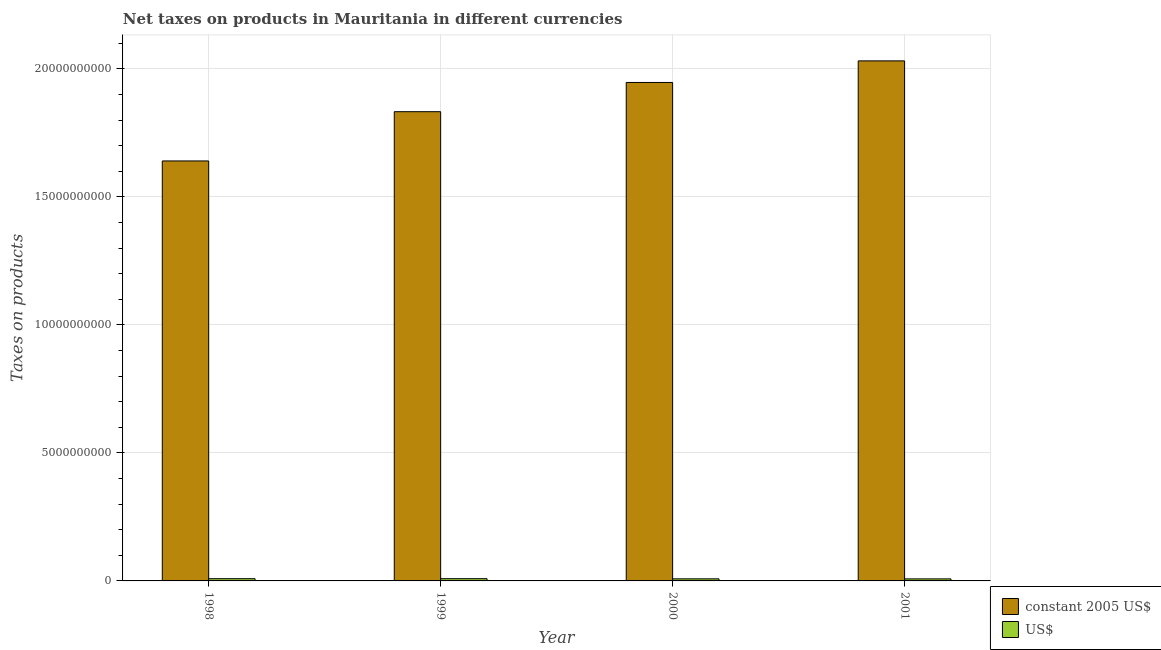Are the number of bars on each tick of the X-axis equal?
Your response must be concise. Yes. How many bars are there on the 3rd tick from the right?
Provide a succinct answer. 2. What is the label of the 4th group of bars from the left?
Give a very brief answer. 2001. What is the net taxes in us$ in 2000?
Give a very brief answer. 8.15e+07. Across all years, what is the maximum net taxes in constant 2005 us$?
Your answer should be very brief. 2.03e+1. Across all years, what is the minimum net taxes in us$?
Make the answer very short. 7.95e+07. In which year was the net taxes in us$ minimum?
Ensure brevity in your answer.  2001. What is the total net taxes in constant 2005 us$ in the graph?
Your response must be concise. 7.45e+1. What is the difference between the net taxes in us$ in 1998 and that in 2000?
Give a very brief answer. 5.55e+06. What is the difference between the net taxes in constant 2005 us$ in 2001 and the net taxes in us$ in 2000?
Your answer should be very brief. 8.43e+08. What is the average net taxes in us$ per year?
Ensure brevity in your answer.  8.39e+07. In the year 2000, what is the difference between the net taxes in constant 2005 us$ and net taxes in us$?
Offer a terse response. 0. In how many years, is the net taxes in constant 2005 us$ greater than 3000000000 units?
Offer a very short reply. 4. What is the ratio of the net taxes in constant 2005 us$ in 2000 to that in 2001?
Your answer should be compact. 0.96. Is the net taxes in us$ in 1999 less than that in 2000?
Provide a short and direct response. No. What is the difference between the highest and the second highest net taxes in constant 2005 us$?
Your answer should be compact. 8.43e+08. What is the difference between the highest and the lowest net taxes in constant 2005 us$?
Ensure brevity in your answer.  3.91e+09. What does the 1st bar from the left in 1999 represents?
Make the answer very short. Constant 2005 us$. What does the 1st bar from the right in 1999 represents?
Your answer should be very brief. US$. How many bars are there?
Offer a terse response. 8. Are all the bars in the graph horizontal?
Offer a terse response. No. What is the difference between two consecutive major ticks on the Y-axis?
Offer a very short reply. 5.00e+09. Does the graph contain any zero values?
Provide a succinct answer. No. Where does the legend appear in the graph?
Ensure brevity in your answer.  Bottom right. What is the title of the graph?
Provide a succinct answer. Net taxes on products in Mauritania in different currencies. What is the label or title of the X-axis?
Offer a very short reply. Year. What is the label or title of the Y-axis?
Your response must be concise. Taxes on products. What is the Taxes on products of constant 2005 US$ in 1998?
Your answer should be compact. 1.64e+1. What is the Taxes on products of US$ in 1998?
Ensure brevity in your answer.  8.70e+07. What is the Taxes on products in constant 2005 US$ in 1999?
Make the answer very short. 1.83e+1. What is the Taxes on products in US$ in 1999?
Keep it short and to the point. 8.75e+07. What is the Taxes on products of constant 2005 US$ in 2000?
Make the answer very short. 1.95e+1. What is the Taxes on products of US$ in 2000?
Your answer should be very brief. 8.15e+07. What is the Taxes on products in constant 2005 US$ in 2001?
Your answer should be very brief. 2.03e+1. What is the Taxes on products in US$ in 2001?
Make the answer very short. 7.95e+07. Across all years, what is the maximum Taxes on products of constant 2005 US$?
Provide a short and direct response. 2.03e+1. Across all years, what is the maximum Taxes on products in US$?
Ensure brevity in your answer.  8.75e+07. Across all years, what is the minimum Taxes on products in constant 2005 US$?
Offer a terse response. 1.64e+1. Across all years, what is the minimum Taxes on products in US$?
Give a very brief answer. 7.95e+07. What is the total Taxes on products in constant 2005 US$ in the graph?
Give a very brief answer. 7.45e+1. What is the total Taxes on products of US$ in the graph?
Your answer should be very brief. 3.35e+08. What is the difference between the Taxes on products in constant 2005 US$ in 1998 and that in 1999?
Give a very brief answer. -1.92e+09. What is the difference between the Taxes on products in US$ in 1998 and that in 1999?
Make the answer very short. -4.43e+05. What is the difference between the Taxes on products of constant 2005 US$ in 1998 and that in 2000?
Make the answer very short. -3.07e+09. What is the difference between the Taxes on products of US$ in 1998 and that in 2000?
Make the answer very short. 5.55e+06. What is the difference between the Taxes on products of constant 2005 US$ in 1998 and that in 2001?
Give a very brief answer. -3.91e+09. What is the difference between the Taxes on products in US$ in 1998 and that in 2001?
Keep it short and to the point. 7.57e+06. What is the difference between the Taxes on products in constant 2005 US$ in 1999 and that in 2000?
Give a very brief answer. -1.14e+09. What is the difference between the Taxes on products of US$ in 1999 and that in 2000?
Provide a succinct answer. 5.99e+06. What is the difference between the Taxes on products of constant 2005 US$ in 1999 and that in 2001?
Your answer should be very brief. -1.98e+09. What is the difference between the Taxes on products of US$ in 1999 and that in 2001?
Ensure brevity in your answer.  8.02e+06. What is the difference between the Taxes on products in constant 2005 US$ in 2000 and that in 2001?
Ensure brevity in your answer.  -8.43e+08. What is the difference between the Taxes on products of US$ in 2000 and that in 2001?
Offer a terse response. 2.03e+06. What is the difference between the Taxes on products in constant 2005 US$ in 1998 and the Taxes on products in US$ in 1999?
Offer a terse response. 1.63e+1. What is the difference between the Taxes on products in constant 2005 US$ in 1998 and the Taxes on products in US$ in 2000?
Provide a succinct answer. 1.63e+1. What is the difference between the Taxes on products of constant 2005 US$ in 1998 and the Taxes on products of US$ in 2001?
Provide a succinct answer. 1.63e+1. What is the difference between the Taxes on products in constant 2005 US$ in 1999 and the Taxes on products in US$ in 2000?
Make the answer very short. 1.82e+1. What is the difference between the Taxes on products of constant 2005 US$ in 1999 and the Taxes on products of US$ in 2001?
Make the answer very short. 1.82e+1. What is the difference between the Taxes on products in constant 2005 US$ in 2000 and the Taxes on products in US$ in 2001?
Ensure brevity in your answer.  1.94e+1. What is the average Taxes on products of constant 2005 US$ per year?
Make the answer very short. 1.86e+1. What is the average Taxes on products in US$ per year?
Your answer should be very brief. 8.39e+07. In the year 1998, what is the difference between the Taxes on products of constant 2005 US$ and Taxes on products of US$?
Ensure brevity in your answer.  1.63e+1. In the year 1999, what is the difference between the Taxes on products of constant 2005 US$ and Taxes on products of US$?
Your answer should be compact. 1.82e+1. In the year 2000, what is the difference between the Taxes on products of constant 2005 US$ and Taxes on products of US$?
Ensure brevity in your answer.  1.94e+1. In the year 2001, what is the difference between the Taxes on products in constant 2005 US$ and Taxes on products in US$?
Ensure brevity in your answer.  2.02e+1. What is the ratio of the Taxes on products in constant 2005 US$ in 1998 to that in 1999?
Make the answer very short. 0.9. What is the ratio of the Taxes on products in US$ in 1998 to that in 1999?
Give a very brief answer. 0.99. What is the ratio of the Taxes on products of constant 2005 US$ in 1998 to that in 2000?
Ensure brevity in your answer.  0.84. What is the ratio of the Taxes on products of US$ in 1998 to that in 2000?
Your answer should be very brief. 1.07. What is the ratio of the Taxes on products of constant 2005 US$ in 1998 to that in 2001?
Offer a terse response. 0.81. What is the ratio of the Taxes on products in US$ in 1998 to that in 2001?
Offer a very short reply. 1.1. What is the ratio of the Taxes on products in constant 2005 US$ in 1999 to that in 2000?
Ensure brevity in your answer.  0.94. What is the ratio of the Taxes on products in US$ in 1999 to that in 2000?
Give a very brief answer. 1.07. What is the ratio of the Taxes on products of constant 2005 US$ in 1999 to that in 2001?
Keep it short and to the point. 0.9. What is the ratio of the Taxes on products of US$ in 1999 to that in 2001?
Provide a succinct answer. 1.1. What is the ratio of the Taxes on products in constant 2005 US$ in 2000 to that in 2001?
Ensure brevity in your answer.  0.96. What is the ratio of the Taxes on products of US$ in 2000 to that in 2001?
Provide a short and direct response. 1.03. What is the difference between the highest and the second highest Taxes on products of constant 2005 US$?
Offer a very short reply. 8.43e+08. What is the difference between the highest and the second highest Taxes on products in US$?
Provide a short and direct response. 4.43e+05. What is the difference between the highest and the lowest Taxes on products of constant 2005 US$?
Provide a succinct answer. 3.91e+09. What is the difference between the highest and the lowest Taxes on products in US$?
Offer a very short reply. 8.02e+06. 